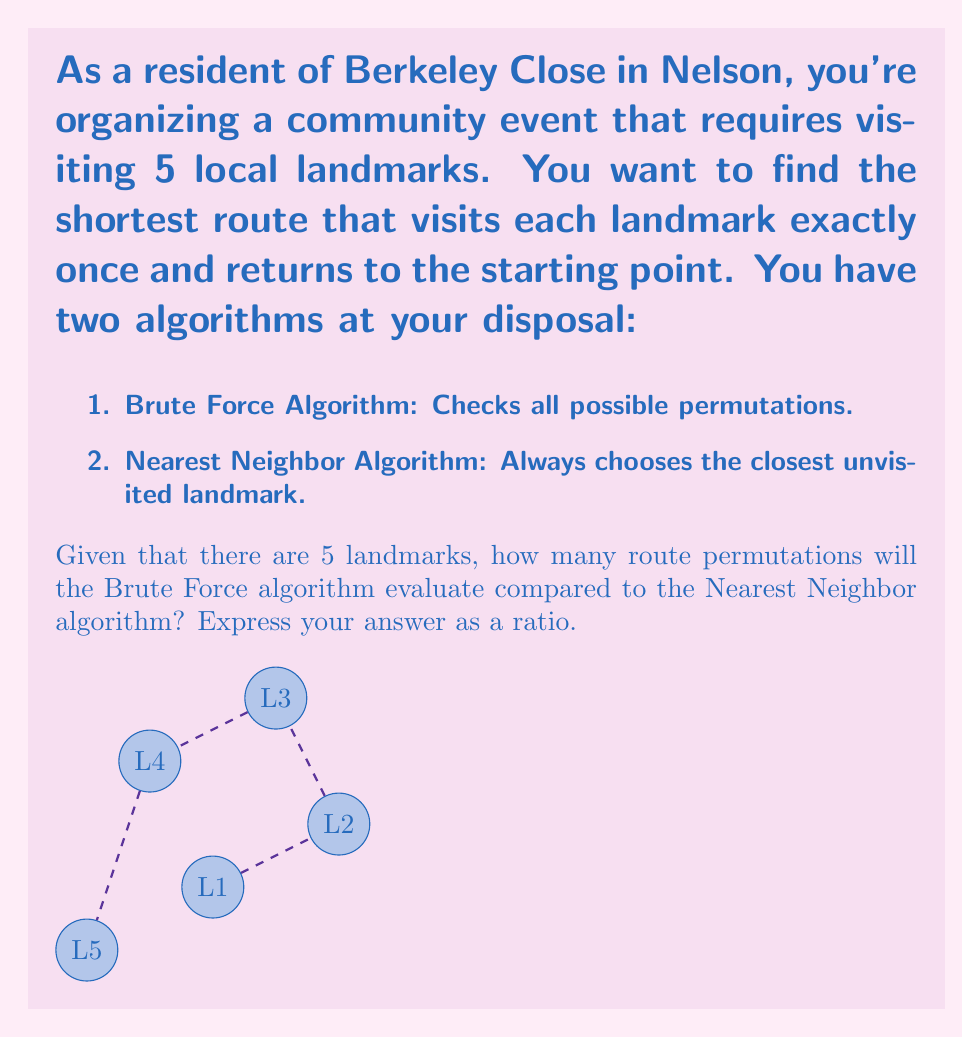Can you solve this math problem? To solve this problem, let's analyze each algorithm:

1. Brute Force Algorithm:
   - This algorithm checks all possible permutations of the landmarks.
   - For n landmarks, there are (n-1)! permutations to check.
   - In this case, with 5 landmarks: (5-1)! = 4! = 24 permutations.

2. Nearest Neighbor Algorithm:
   - This algorithm makes a single choice at each step.
   - It starts at one landmark and always moves to the nearest unvisited landmark.
   - It makes (n-1) choices for n landmarks.
   - In this case, with 5 landmarks, it makes 4 choices.

To express this as a ratio:

$$\frac{\text{Brute Force evaluations}}{\text{Nearest Neighbor evaluations}} = \frac{24}{4} = 6$$

Therefore, the Brute Force algorithm evaluates 6 times more routes than the Nearest Neighbor algorithm for this 5-landmark problem.
Answer: 6:1 